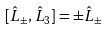<formula> <loc_0><loc_0><loc_500><loc_500>[ { \hat { L } } _ { \pm } , { \hat { L } } _ { 3 } ] = \pm { \hat { L } } _ { \pm }</formula> 